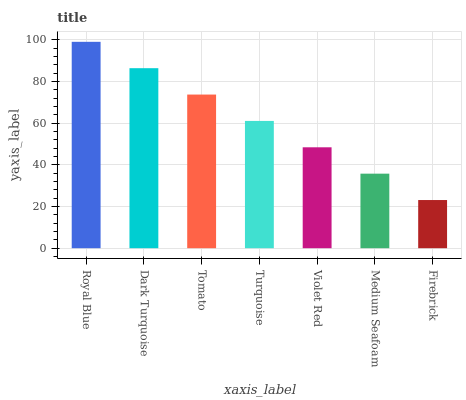Is Dark Turquoise the minimum?
Answer yes or no. No. Is Dark Turquoise the maximum?
Answer yes or no. No. Is Royal Blue greater than Dark Turquoise?
Answer yes or no. Yes. Is Dark Turquoise less than Royal Blue?
Answer yes or no. Yes. Is Dark Turquoise greater than Royal Blue?
Answer yes or no. No. Is Royal Blue less than Dark Turquoise?
Answer yes or no. No. Is Turquoise the high median?
Answer yes or no. Yes. Is Turquoise the low median?
Answer yes or no. Yes. Is Violet Red the high median?
Answer yes or no. No. Is Firebrick the low median?
Answer yes or no. No. 